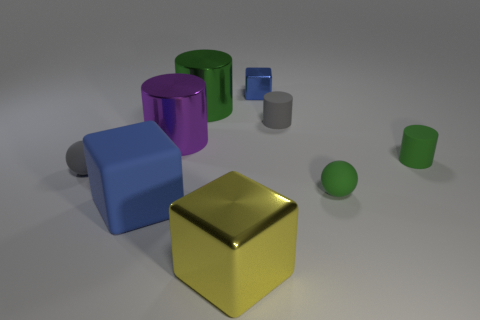The matte thing that is behind the blue matte cube and to the left of the small blue shiny object has what shape?
Your answer should be very brief. Sphere. Are there more tiny spheres left of the blue metal object than red rubber cubes?
Offer a very short reply. Yes. The other cylinder that is made of the same material as the gray cylinder is what size?
Offer a very short reply. Small. What number of small balls are the same color as the tiny cube?
Offer a terse response. 0. There is a small object that is behind the big green shiny object; does it have the same color as the large matte cube?
Offer a very short reply. Yes. Is the number of small cylinders that are behind the green shiny object the same as the number of small blue things that are to the right of the big blue cube?
Give a very brief answer. No. There is a tiny cylinder that is left of the small green matte cylinder; what color is it?
Your answer should be very brief. Gray. Are there an equal number of tiny things left of the tiny metallic block and blue matte objects?
Provide a short and direct response. Yes. How many other objects are there of the same shape as the small blue object?
Provide a succinct answer. 2. There is a tiny metal thing; what number of big shiny objects are behind it?
Your response must be concise. 0. 